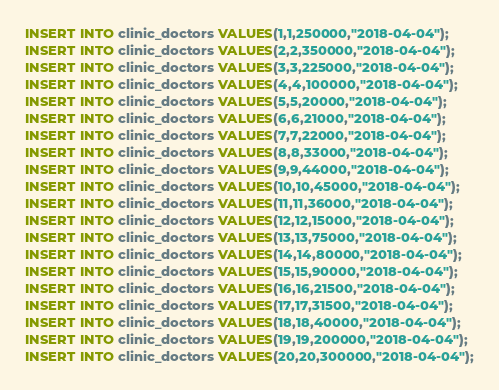Convert code to text. <code><loc_0><loc_0><loc_500><loc_500><_SQL_>INSERT INTO clinic_doctors VALUES(1,1,250000,"2018-04-04");
INSERT INTO clinic_doctors VALUES(2,2,350000,"2018-04-04");
INSERT INTO clinic_doctors VALUES(3,3,225000,"2018-04-04");
INSERT INTO clinic_doctors VALUES(4,4,100000,"2018-04-04");
INSERT INTO clinic_doctors VALUES(5,5,20000,"2018-04-04");
INSERT INTO clinic_doctors VALUES(6,6,21000,"2018-04-04");
INSERT INTO clinic_doctors VALUES(7,7,22000,"2018-04-04");
INSERT INTO clinic_doctors VALUES(8,8,33000,"2018-04-04");
INSERT INTO clinic_doctors VALUES(9,9,44000,"2018-04-04");
INSERT INTO clinic_doctors VALUES(10,10,45000,"2018-04-04");
INSERT INTO clinic_doctors VALUES(11,11,36000,"2018-04-04");
INSERT INTO clinic_doctors VALUES(12,12,15000,"2018-04-04");
INSERT INTO clinic_doctors VALUES(13,13,75000,"2018-04-04");
INSERT INTO clinic_doctors VALUES(14,14,80000,"2018-04-04");
INSERT INTO clinic_doctors VALUES(15,15,90000,"2018-04-04");
INSERT INTO clinic_doctors VALUES(16,16,21500,"2018-04-04");
INSERT INTO clinic_doctors VALUES(17,17,31500,"2018-04-04");
INSERT INTO clinic_doctors VALUES(18,18,40000,"2018-04-04");
INSERT INTO clinic_doctors VALUES(19,19,200000,"2018-04-04");
INSERT INTO clinic_doctors VALUES(20,20,300000,"2018-04-04");
</code> 